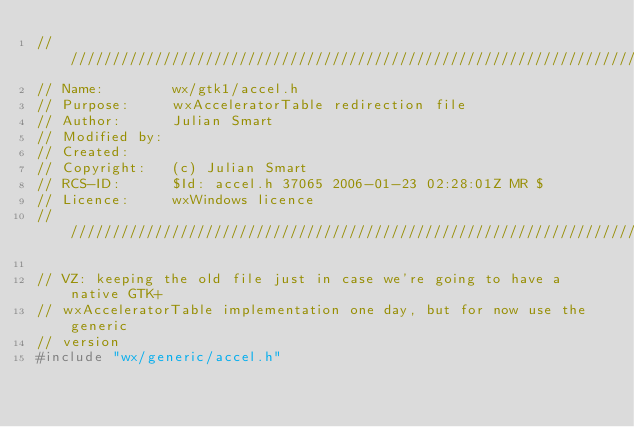Convert code to text. <code><loc_0><loc_0><loc_500><loc_500><_C_>/////////////////////////////////////////////////////////////////////////////
// Name:        wx/gtk1/accel.h
// Purpose:     wxAcceleratorTable redirection file
// Author:      Julian Smart
// Modified by:
// Created:
// Copyright:   (c) Julian Smart
// RCS-ID:      $Id: accel.h 37065 2006-01-23 02:28:01Z MR $
// Licence:     wxWindows licence
/////////////////////////////////////////////////////////////////////////////

// VZ: keeping the old file just in case we're going to have a native GTK+
// wxAcceleratorTable implementation one day, but for now use the generic
// version
#include "wx/generic/accel.h"
</code> 